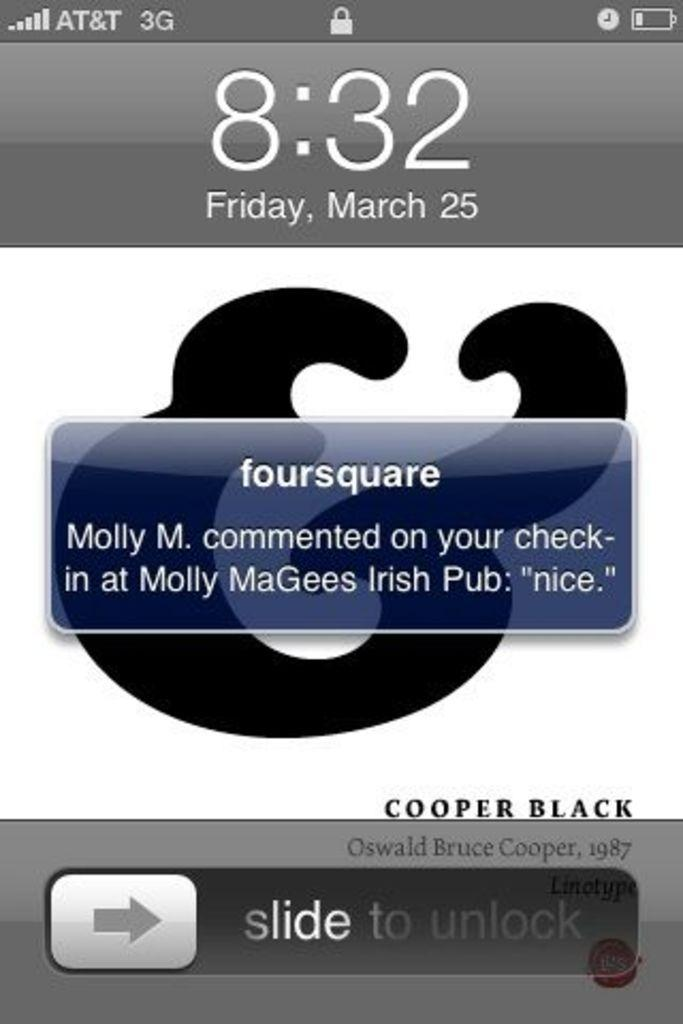Provide a one-sentence caption for the provided image. The phone screen states that the time is currently 8:32. 